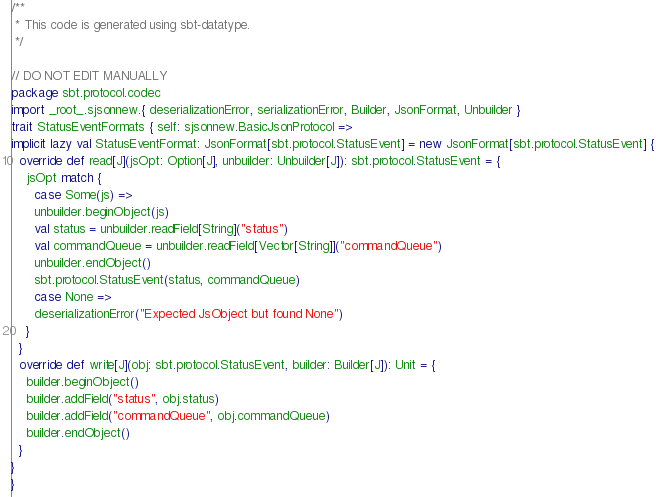Convert code to text. <code><loc_0><loc_0><loc_500><loc_500><_Scala_>/**
 * This code is generated using sbt-datatype.
 */

// DO NOT EDIT MANUALLY
package sbt.protocol.codec
import _root_.sjsonnew.{ deserializationError, serializationError, Builder, JsonFormat, Unbuilder }
trait StatusEventFormats { self: sjsonnew.BasicJsonProtocol =>
implicit lazy val StatusEventFormat: JsonFormat[sbt.protocol.StatusEvent] = new JsonFormat[sbt.protocol.StatusEvent] {
  override def read[J](jsOpt: Option[J], unbuilder: Unbuilder[J]): sbt.protocol.StatusEvent = {
    jsOpt match {
      case Some(js) =>
      unbuilder.beginObject(js)
      val status = unbuilder.readField[String]("status")
      val commandQueue = unbuilder.readField[Vector[String]]("commandQueue")
      unbuilder.endObject()
      sbt.protocol.StatusEvent(status, commandQueue)
      case None =>
      deserializationError("Expected JsObject but found None")
    }
  }
  override def write[J](obj: sbt.protocol.StatusEvent, builder: Builder[J]): Unit = {
    builder.beginObject()
    builder.addField("status", obj.status)
    builder.addField("commandQueue", obj.commandQueue)
    builder.endObject()
  }
}
}
</code> 